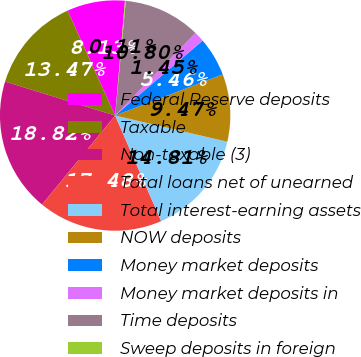<chart> <loc_0><loc_0><loc_500><loc_500><pie_chart><fcel>Federal Reserve deposits<fcel>Taxable<fcel>Non-taxable (3)<fcel>Total loans net of unearned<fcel>Total interest-earning assets<fcel>NOW deposits<fcel>Money market deposits<fcel>Money market deposits in<fcel>Time deposits<fcel>Sweep deposits in foreign<nl><fcel>8.13%<fcel>13.47%<fcel>18.82%<fcel>17.48%<fcel>14.81%<fcel>9.47%<fcel>5.46%<fcel>1.45%<fcel>10.8%<fcel>0.11%<nl></chart> 